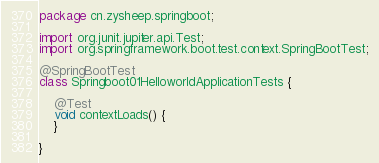<code> <loc_0><loc_0><loc_500><loc_500><_Java_>package cn.zysheep.springboot;

import org.junit.jupiter.api.Test;
import org.springframework.boot.test.context.SpringBootTest;

@SpringBootTest
class Springboot01HelloworldApplicationTests {

    @Test
    void contextLoads() {
    }

}
</code> 